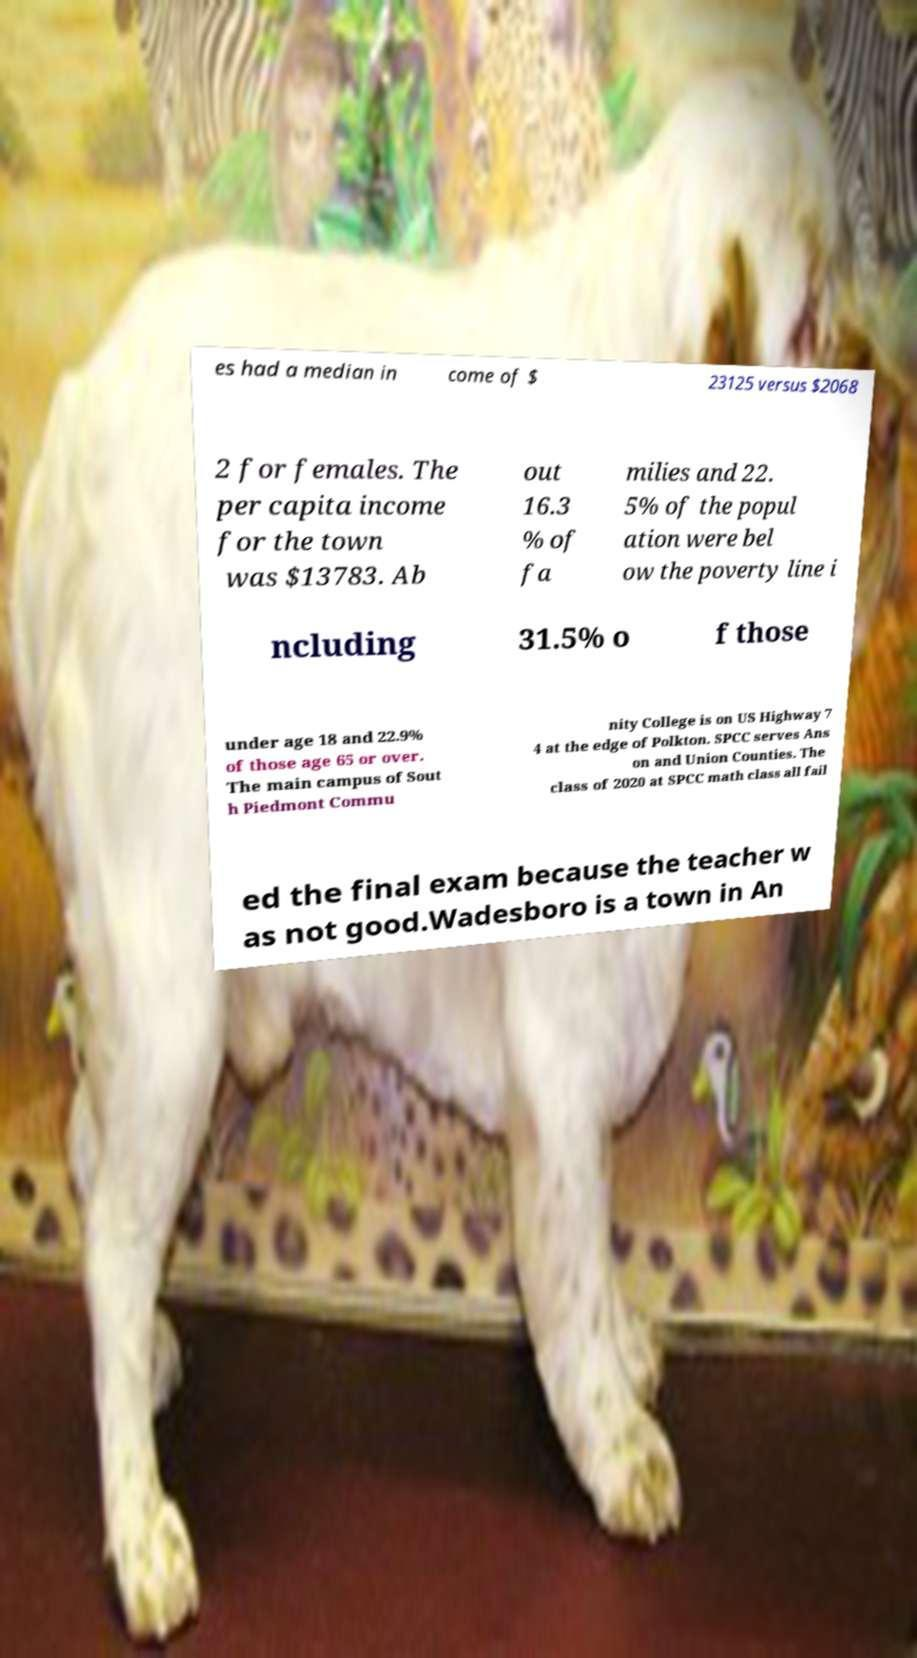What messages or text are displayed in this image? I need them in a readable, typed format. es had a median in come of $ 23125 versus $2068 2 for females. The per capita income for the town was $13783. Ab out 16.3 % of fa milies and 22. 5% of the popul ation were bel ow the poverty line i ncluding 31.5% o f those under age 18 and 22.9% of those age 65 or over. The main campus of Sout h Piedmont Commu nity College is on US Highway 7 4 at the edge of Polkton. SPCC serves Ans on and Union Counties. The class of 2020 at SPCC math class all fail ed the final exam because the teacher w as not good.Wadesboro is a town in An 